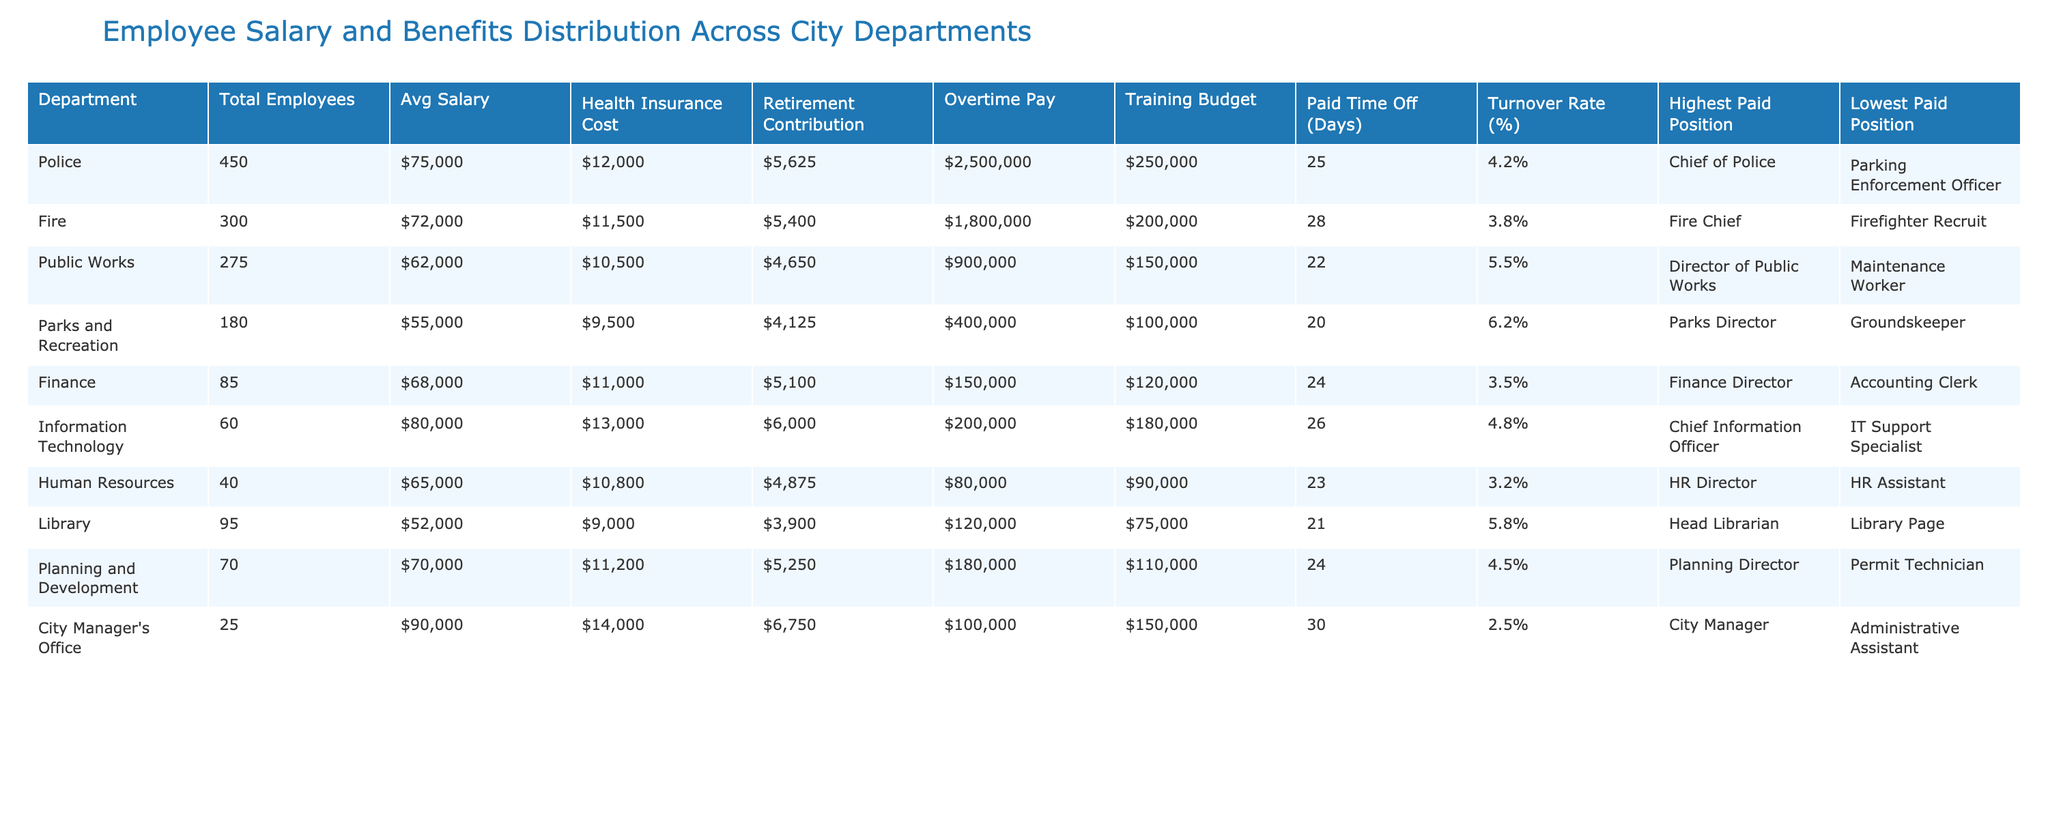What is the average salary for employees in the Fire department? The table indicates that the average salary for the Fire department is listed as 72,000. Thus, the average salary corresponds directly to the value found in the column for Average Salary under the Fire department.
Answer: 72,000 What is the health insurance cost for the lowest paid position in the Police department? The table shows that the lowest paid position in the Police department is the Parking Enforcement Officer. The health insurance cost provided in the table is 12,000, which applies to all employees in the department, including the lowest paid position.
Answer: 12,000 Which department has the highest turnover rate? To find the highest turnover rate, we examine the Turnover Rate (%) column and compare values. The Parks and Recreation department has the highest turnover rate at 6.2%, which is greater than all other departments.
Answer: Parks and Recreation What is the difference between the average salary in the Finance department and the average salary in the Library? The finance department has an average salary of 68,000, while the library has an average of 52,000. The difference is calculated as 68,000 - 52,000 = 16,000.
Answer: 16,000 Which department has the lowest training budget? By reviewing the Training Budget column, we see the Human Resources department has the lowest training budget at 80,000, which is less than any other department listed.
Answer: Human Resources What is the total overtime pay for all employees in the Public Works department? The table specifies that the total overtime pay for the Public Works department is listed as 900,000. Therefore, we can conclude that this is the total amount for all employees within that department.
Answer: 900,000 Are there any departments where the turnover rate is below 4%? By checking the Turnover Rate (%) column, it is evident that all departments have turnover rates that are 4% or higher. Thus, there are no departments with a turnover rate below 4%.
Answer: No Calculate the total average salary for all departments combined. We first sum the average salaries for all departments: (75,000 + 72,000 + 62,000 + 55,000 + 68,000 + 80,000 + 65,000 + 52,000 + 70,000 + 90,000) =  72,500, then divide by the number of departments, which is 10. The total average salary is 725,000 / 10 = 72,500.
Answer: 72,500 What is the highest average salary and which department has it? In the Avg Salary column, the highest average salary is 90,000, corresponding to the City Manager's Office. This is the only entry at that salary level, making it the highest.
Answer: City Manager's Office Is the average health insurance cost for the Fire department greater than that of the Public Works department? The Fire department has a health insurance cost of 11,500, while the Public Works department has a cost of 10,500. Since 11,500 is greater than 10,500, the statement is true.
Answer: Yes 